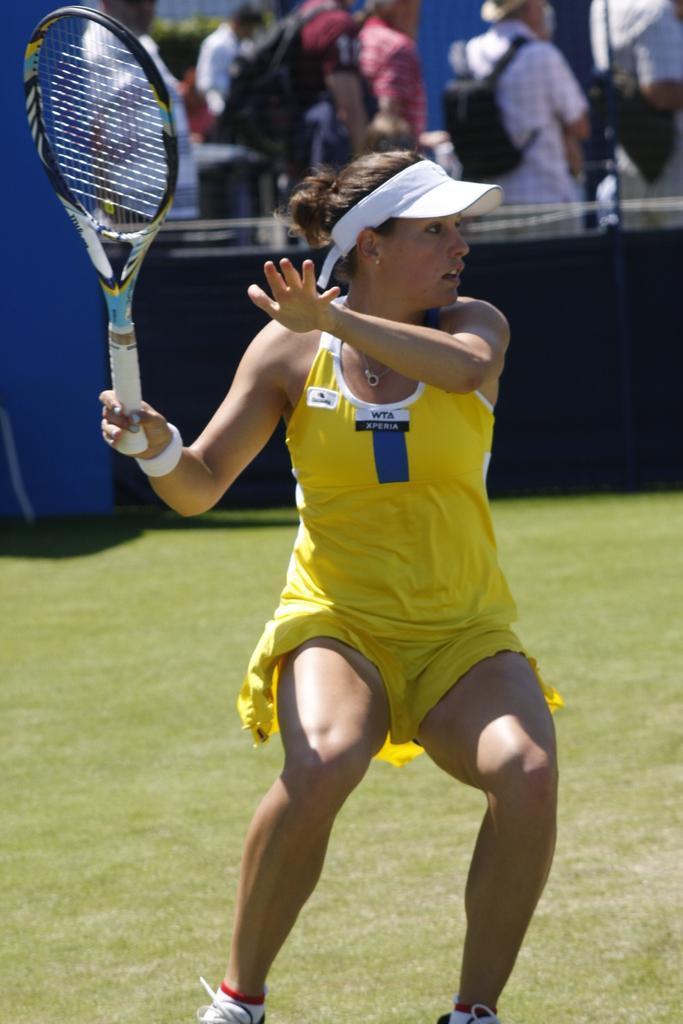Could you give a brief overview of what you see in this image? Here we can see a woman is standing on the ground and holding a racket in her hands, and at back here a group of people are standing. 